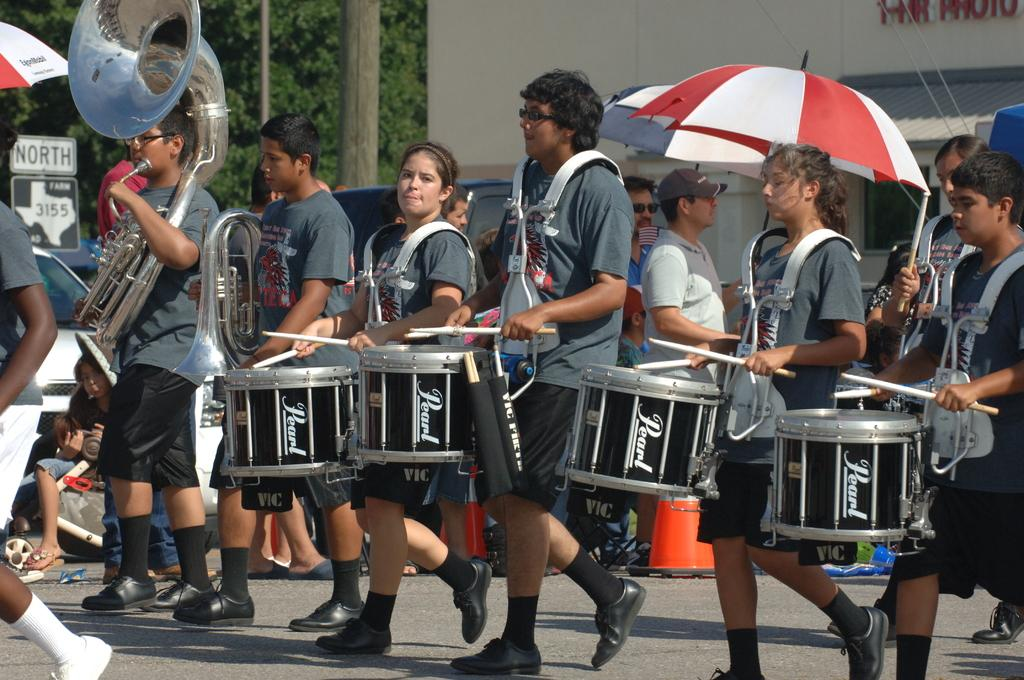What are the persons in the image doing? The persons in the image are playing drums. What can be seen in the background of the image? There are trees, a vehicle, and a building in the background of the image. What is the weight of the beef being cooked on the grill in the image? There is no grill or beef present in the image; the persons are playing drums, and the background features trees, a vehicle, and a building. 